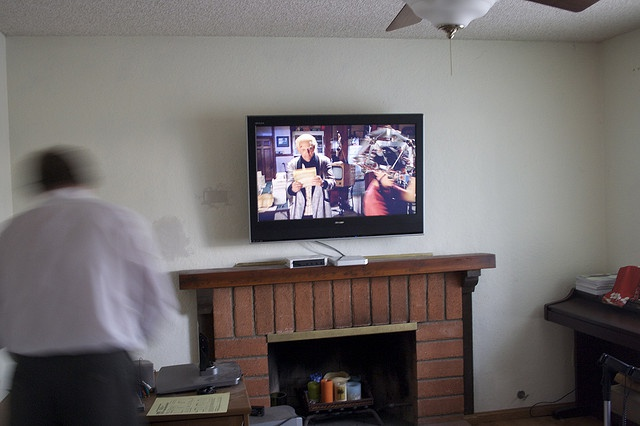Describe the objects in this image and their specific colors. I can see people in gray, black, and darkgray tones, tv in gray, black, lavender, and navy tones, book in gray, darkgray, and black tones, and book in gray and black tones in this image. 